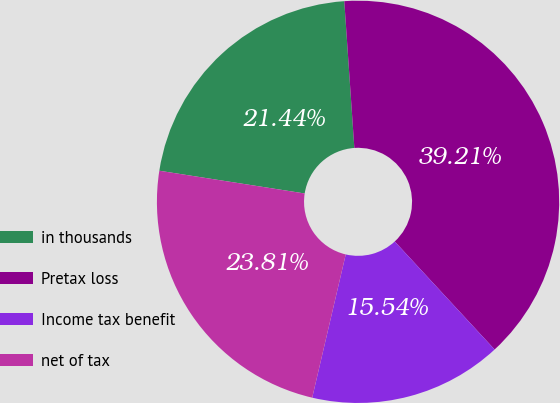Convert chart. <chart><loc_0><loc_0><loc_500><loc_500><pie_chart><fcel>in thousands<fcel>Pretax loss<fcel>Income tax benefit<fcel>net of tax<nl><fcel>21.44%<fcel>39.21%<fcel>15.54%<fcel>23.81%<nl></chart> 